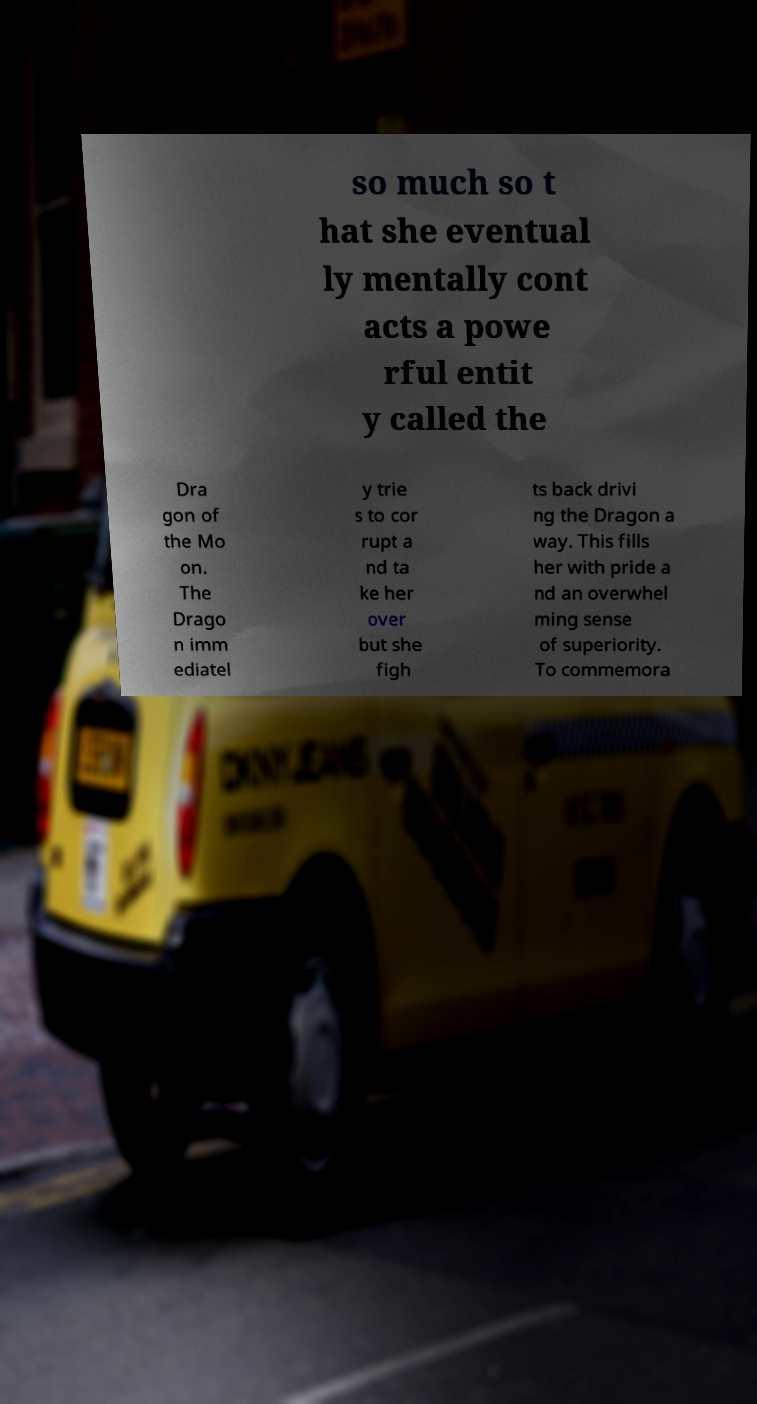Can you read and provide the text displayed in the image?This photo seems to have some interesting text. Can you extract and type it out for me? so much so t hat she eventual ly mentally cont acts a powe rful entit y called the Dra gon of the Mo on. The Drago n imm ediatel y trie s to cor rupt a nd ta ke her over but she figh ts back drivi ng the Dragon a way. This fills her with pride a nd an overwhel ming sense of superiority. To commemora 